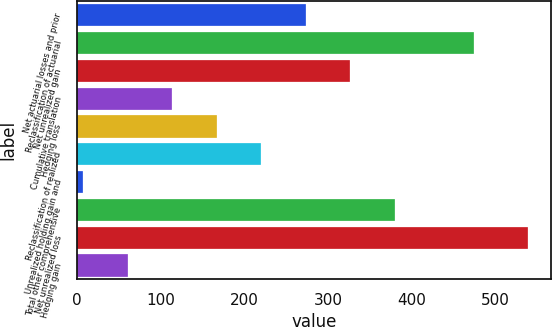<chart> <loc_0><loc_0><loc_500><loc_500><bar_chart><fcel>Net actuarial losses and prior<fcel>Reclassification of actuarial<fcel>Net unrealized gain<fcel>Cumulative translation<fcel>Hedging loss<fcel>Reclassification of realized<fcel>Unrealized holding gain and<fcel>Total other comprehensive<fcel>Net unrealized loss<fcel>Hedging gain<nl><fcel>273.5<fcel>474<fcel>326.6<fcel>114.2<fcel>167.3<fcel>220.4<fcel>8<fcel>379.7<fcel>539<fcel>61.1<nl></chart> 